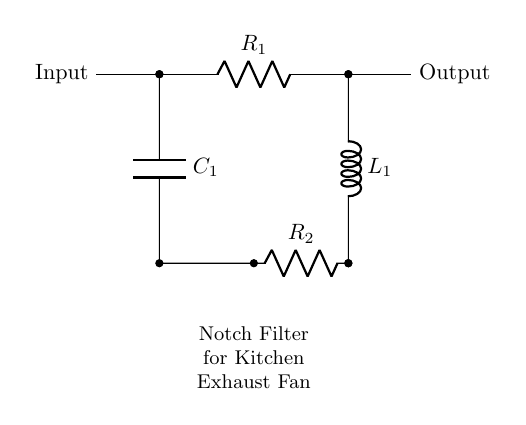What is the input of the circuit? The circuit shows an input terminal on the left side, indicating where the signal enters the notch filter.
Answer: Input What component is used for noise reduction? The combination of a resistor, capacitor, and inductor forms a notch filter which reduces the specific frequency noise.
Answer: R, C, L How many resistors are present in the circuit? There are two resistors indicated in the diagram, both labeled R1 and R2, connected appropriately.
Answer: 2 What is the purpose of C1 in the circuit? C1 acts as a capacitive element that interacts with the resistors and inductor to filter out unwanted noise frequencies.
Answer: Filter Describe the type of filter represented in the circuit. This circuit represents a notch filter, which is specifically designed to reject a narrow band of frequencies while allowing others to pass through.
Answer: Notch filter What is the output of the circuit? The output terminal is located on the right side of the circuit, where the filtered signal is available after processing through the filter components.
Answer: Output 